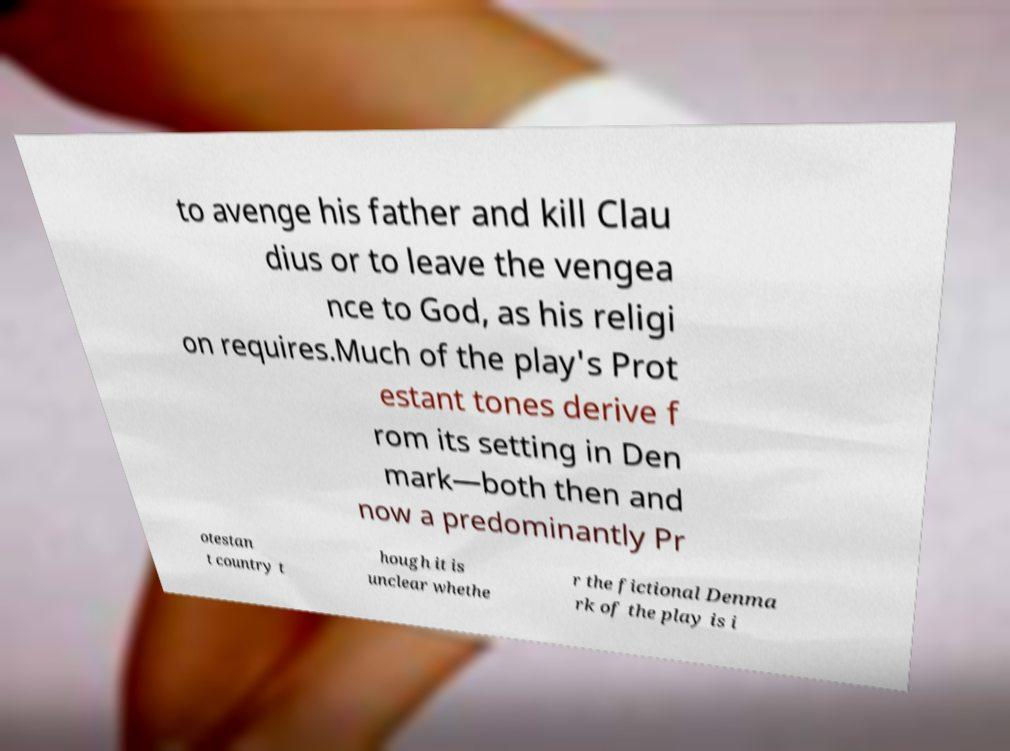I need the written content from this picture converted into text. Can you do that? to avenge his father and kill Clau dius or to leave the vengea nce to God, as his religi on requires.Much of the play's Prot estant tones derive f rom its setting in Den mark—both then and now a predominantly Pr otestan t country t hough it is unclear whethe r the fictional Denma rk of the play is i 